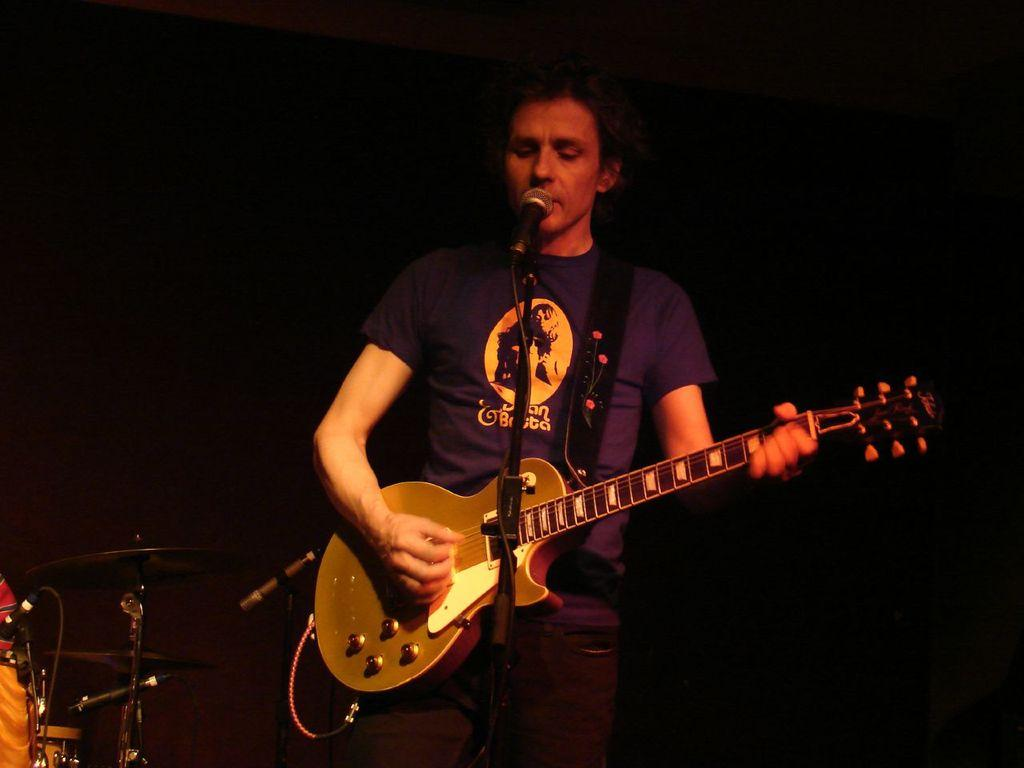What is the main subject of the image? There is a person in the image. What is the person doing in the image? The person is standing, playing a guitar, and singing into a microphone. What else can be seen in the image besides the person? There are musical instruments to the left of the person. What type of effect does the father have on the texture of the image? There is no father present in the image, and therefore no effect on the texture can be observed. 